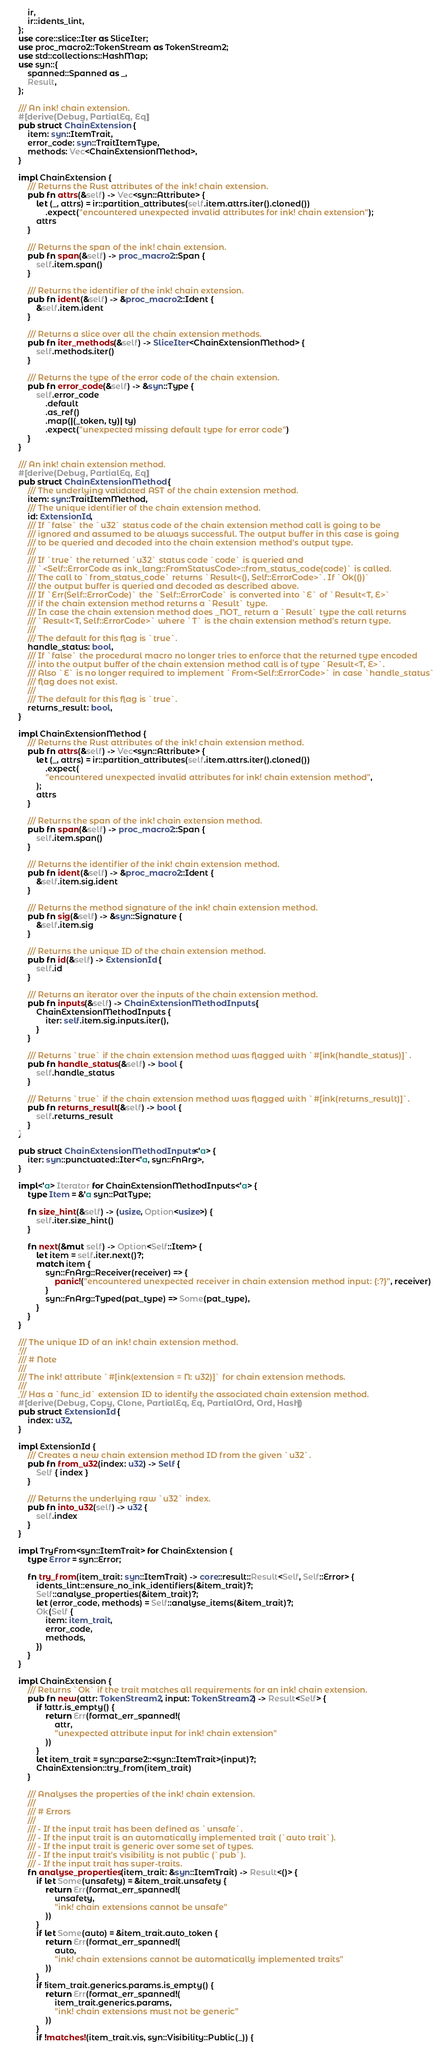Convert code to text. <code><loc_0><loc_0><loc_500><loc_500><_Rust_>    ir,
    ir::idents_lint,
};
use core::slice::Iter as SliceIter;
use proc_macro2::TokenStream as TokenStream2;
use std::collections::HashMap;
use syn::{
    spanned::Spanned as _,
    Result,
};

/// An ink! chain extension.
#[derive(Debug, PartialEq, Eq)]
pub struct ChainExtension {
    item: syn::ItemTrait,
    error_code: syn::TraitItemType,
    methods: Vec<ChainExtensionMethod>,
}

impl ChainExtension {
    /// Returns the Rust attributes of the ink! chain extension.
    pub fn attrs(&self) -> Vec<syn::Attribute> {
        let (_, attrs) = ir::partition_attributes(self.item.attrs.iter().cloned())
            .expect("encountered unexpected invalid attributes for ink! chain extension");
        attrs
    }

    /// Returns the span of the ink! chain extension.
    pub fn span(&self) -> proc_macro2::Span {
        self.item.span()
    }

    /// Returns the identifier of the ink! chain extension.
    pub fn ident(&self) -> &proc_macro2::Ident {
        &self.item.ident
    }

    /// Returns a slice over all the chain extension methods.
    pub fn iter_methods(&self) -> SliceIter<ChainExtensionMethod> {
        self.methods.iter()
    }

    /// Returns the type of the error code of the chain extension.
    pub fn error_code(&self) -> &syn::Type {
        self.error_code
            .default
            .as_ref()
            .map(|(_token, ty)| ty)
            .expect("unexpected missing default type for error code")
    }
}

/// An ink! chain extension method.
#[derive(Debug, PartialEq, Eq)]
pub struct ChainExtensionMethod {
    /// The underlying validated AST of the chain extension method.
    item: syn::TraitItemMethod,
    /// The unique identifier of the chain extension method.
    id: ExtensionId,
    /// If `false` the `u32` status code of the chain extension method call is going to be
    /// ignored and assumed to be always successful. The output buffer in this case is going
    /// to be queried and decoded into the chain extension method's output type.
    ///
    /// If `true` the returned `u32` status code `code` is queried and
    /// `<Self::ErrorCode as ink_lang::FromStatusCode>::from_status_code(code)` is called.
    /// The call to `from_status_code` returns `Result<(), Self::ErrorCode>`. If `Ok(())`
    /// the output buffer is queried and decoded as described above.
    /// If `Err(Self::ErrorCode)` the `Self::ErrorCode` is converted into `E` of `Result<T, E>`
    /// if the chain extension method returns a `Result` type.
    /// In case the chain extension method does _NOT_ return a `Result` type the call returns
    /// `Result<T, Self::ErrorCode>` where `T` is the chain extension method's return type.
    ///
    /// The default for this flag is `true`.
    handle_status: bool,
    /// If `false` the procedural macro no longer tries to enforce that the returned type encoded
    /// into the output buffer of the chain extension method call is of type `Result<T, E>`.
    /// Also `E` is no longer required to implement `From<Self::ErrorCode>` in case `handle_status`
    /// flag does not exist.
    ///
    /// The default for this flag is `true`.
    returns_result: bool,
}

impl ChainExtensionMethod {
    /// Returns the Rust attributes of the ink! chain extension method.
    pub fn attrs(&self) -> Vec<syn::Attribute> {
        let (_, attrs) = ir::partition_attributes(self.item.attrs.iter().cloned())
            .expect(
            "encountered unexpected invalid attributes for ink! chain extension method",
        );
        attrs
    }

    /// Returns the span of the ink! chain extension method.
    pub fn span(&self) -> proc_macro2::Span {
        self.item.span()
    }

    /// Returns the identifier of the ink! chain extension method.
    pub fn ident(&self) -> &proc_macro2::Ident {
        &self.item.sig.ident
    }

    /// Returns the method signature of the ink! chain extension method.
    pub fn sig(&self) -> &syn::Signature {
        &self.item.sig
    }

    /// Returns the unique ID of the chain extension method.
    pub fn id(&self) -> ExtensionId {
        self.id
    }

    /// Returns an iterator over the inputs of the chain extension method.
    pub fn inputs(&self) -> ChainExtensionMethodInputs {
        ChainExtensionMethodInputs {
            iter: self.item.sig.inputs.iter(),
        }
    }

    /// Returns `true` if the chain extension method was flagged with `#[ink(handle_status)]`.
    pub fn handle_status(&self) -> bool {
        self.handle_status
    }

    /// Returns `true` if the chain extension method was flagged with `#[ink(returns_result)]`.
    pub fn returns_result(&self) -> bool {
        self.returns_result
    }
}

pub struct ChainExtensionMethodInputs<'a> {
    iter: syn::punctuated::Iter<'a, syn::FnArg>,
}

impl<'a> Iterator for ChainExtensionMethodInputs<'a> {
    type Item = &'a syn::PatType;

    fn size_hint(&self) -> (usize, Option<usize>) {
        self.iter.size_hint()
    }

    fn next(&mut self) -> Option<Self::Item> {
        let item = self.iter.next()?;
        match item {
            syn::FnArg::Receiver(receiver) => {
                panic!("encountered unexpected receiver in chain extension method input: {:?}", receiver)
            }
            syn::FnArg::Typed(pat_type) => Some(pat_type),
        }
    }
}

/// The unique ID of an ink! chain extension method.
///
/// # Note
///
/// The ink! attribute `#[ink(extension = N: u32)]` for chain extension methods.
///
/// Has a `func_id` extension ID to identify the associated chain extension method.
#[derive(Debug, Copy, Clone, PartialEq, Eq, PartialOrd, Ord, Hash)]
pub struct ExtensionId {
    index: u32,
}

impl ExtensionId {
    /// Creates a new chain extension method ID from the given `u32`.
    pub fn from_u32(index: u32) -> Self {
        Self { index }
    }

    /// Returns the underlying raw `u32` index.
    pub fn into_u32(self) -> u32 {
        self.index
    }
}

impl TryFrom<syn::ItemTrait> for ChainExtension {
    type Error = syn::Error;

    fn try_from(item_trait: syn::ItemTrait) -> core::result::Result<Self, Self::Error> {
        idents_lint::ensure_no_ink_identifiers(&item_trait)?;
        Self::analyse_properties(&item_trait)?;
        let (error_code, methods) = Self::analyse_items(&item_trait)?;
        Ok(Self {
            item: item_trait,
            error_code,
            methods,
        })
    }
}

impl ChainExtension {
    /// Returns `Ok` if the trait matches all requirements for an ink! chain extension.
    pub fn new(attr: TokenStream2, input: TokenStream2) -> Result<Self> {
        if !attr.is_empty() {
            return Err(format_err_spanned!(
                attr,
                "unexpected attribute input for ink! chain extension"
            ))
        }
        let item_trait = syn::parse2::<syn::ItemTrait>(input)?;
        ChainExtension::try_from(item_trait)
    }

    /// Analyses the properties of the ink! chain extension.
    ///
    /// # Errors
    ///
    /// - If the input trait has been defined as `unsafe`.
    /// - If the input trait is an automatically implemented trait (`auto trait`).
    /// - If the input trait is generic over some set of types.
    /// - If the input trait's visibility is not public (`pub`).
    /// - If the input trait has super-traits.
    fn analyse_properties(item_trait: &syn::ItemTrait) -> Result<()> {
        if let Some(unsafety) = &item_trait.unsafety {
            return Err(format_err_spanned!(
                unsafety,
                "ink! chain extensions cannot be unsafe"
            ))
        }
        if let Some(auto) = &item_trait.auto_token {
            return Err(format_err_spanned!(
                auto,
                "ink! chain extensions cannot be automatically implemented traits"
            ))
        }
        if !item_trait.generics.params.is_empty() {
            return Err(format_err_spanned!(
                item_trait.generics.params,
                "ink! chain extensions must not be generic"
            ))
        }
        if !matches!(item_trait.vis, syn::Visibility::Public(_)) {</code> 